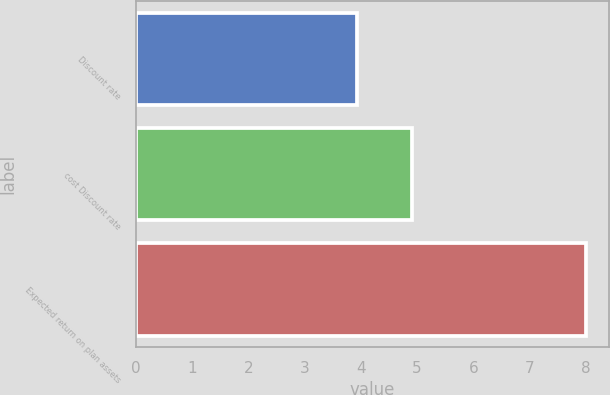Convert chart to OTSL. <chart><loc_0><loc_0><loc_500><loc_500><bar_chart><fcel>Discount rate<fcel>cost Discount rate<fcel>Expected return on plan assets<nl><fcel>3.93<fcel>4.9<fcel>8<nl></chart> 